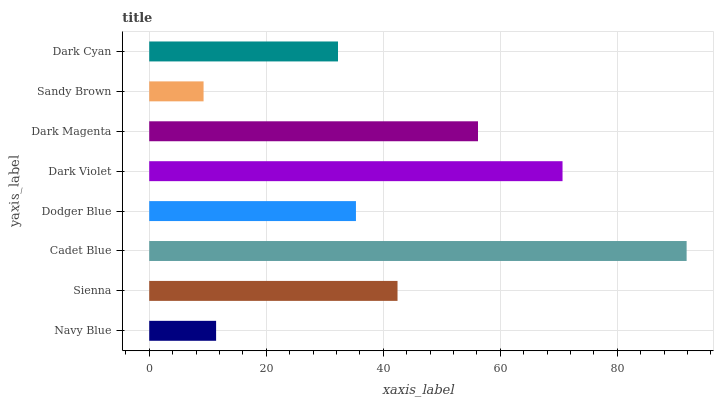Is Sandy Brown the minimum?
Answer yes or no. Yes. Is Cadet Blue the maximum?
Answer yes or no. Yes. Is Sienna the minimum?
Answer yes or no. No. Is Sienna the maximum?
Answer yes or no. No. Is Sienna greater than Navy Blue?
Answer yes or no. Yes. Is Navy Blue less than Sienna?
Answer yes or no. Yes. Is Navy Blue greater than Sienna?
Answer yes or no. No. Is Sienna less than Navy Blue?
Answer yes or no. No. Is Sienna the high median?
Answer yes or no. Yes. Is Dodger Blue the low median?
Answer yes or no. Yes. Is Dark Violet the high median?
Answer yes or no. No. Is Dark Magenta the low median?
Answer yes or no. No. 